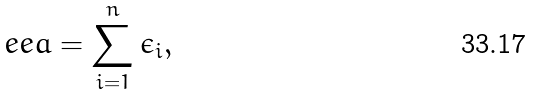Convert formula to latex. <formula><loc_0><loc_0><loc_500><loc_500>\ e e a = \sum _ { i = 1 } ^ { n } \epsilon _ { i } ,</formula> 